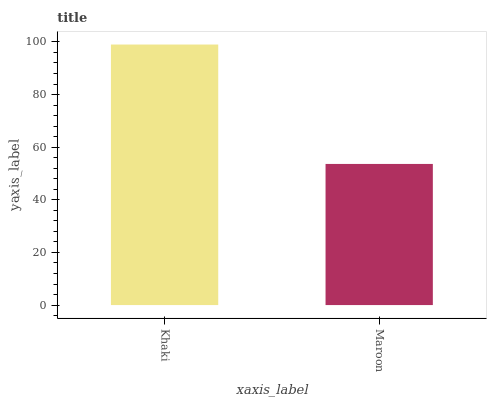Is Maroon the minimum?
Answer yes or no. Yes. Is Khaki the maximum?
Answer yes or no. Yes. Is Maroon the maximum?
Answer yes or no. No. Is Khaki greater than Maroon?
Answer yes or no. Yes. Is Maroon less than Khaki?
Answer yes or no. Yes. Is Maroon greater than Khaki?
Answer yes or no. No. Is Khaki less than Maroon?
Answer yes or no. No. Is Khaki the high median?
Answer yes or no. Yes. Is Maroon the low median?
Answer yes or no. Yes. Is Maroon the high median?
Answer yes or no. No. Is Khaki the low median?
Answer yes or no. No. 